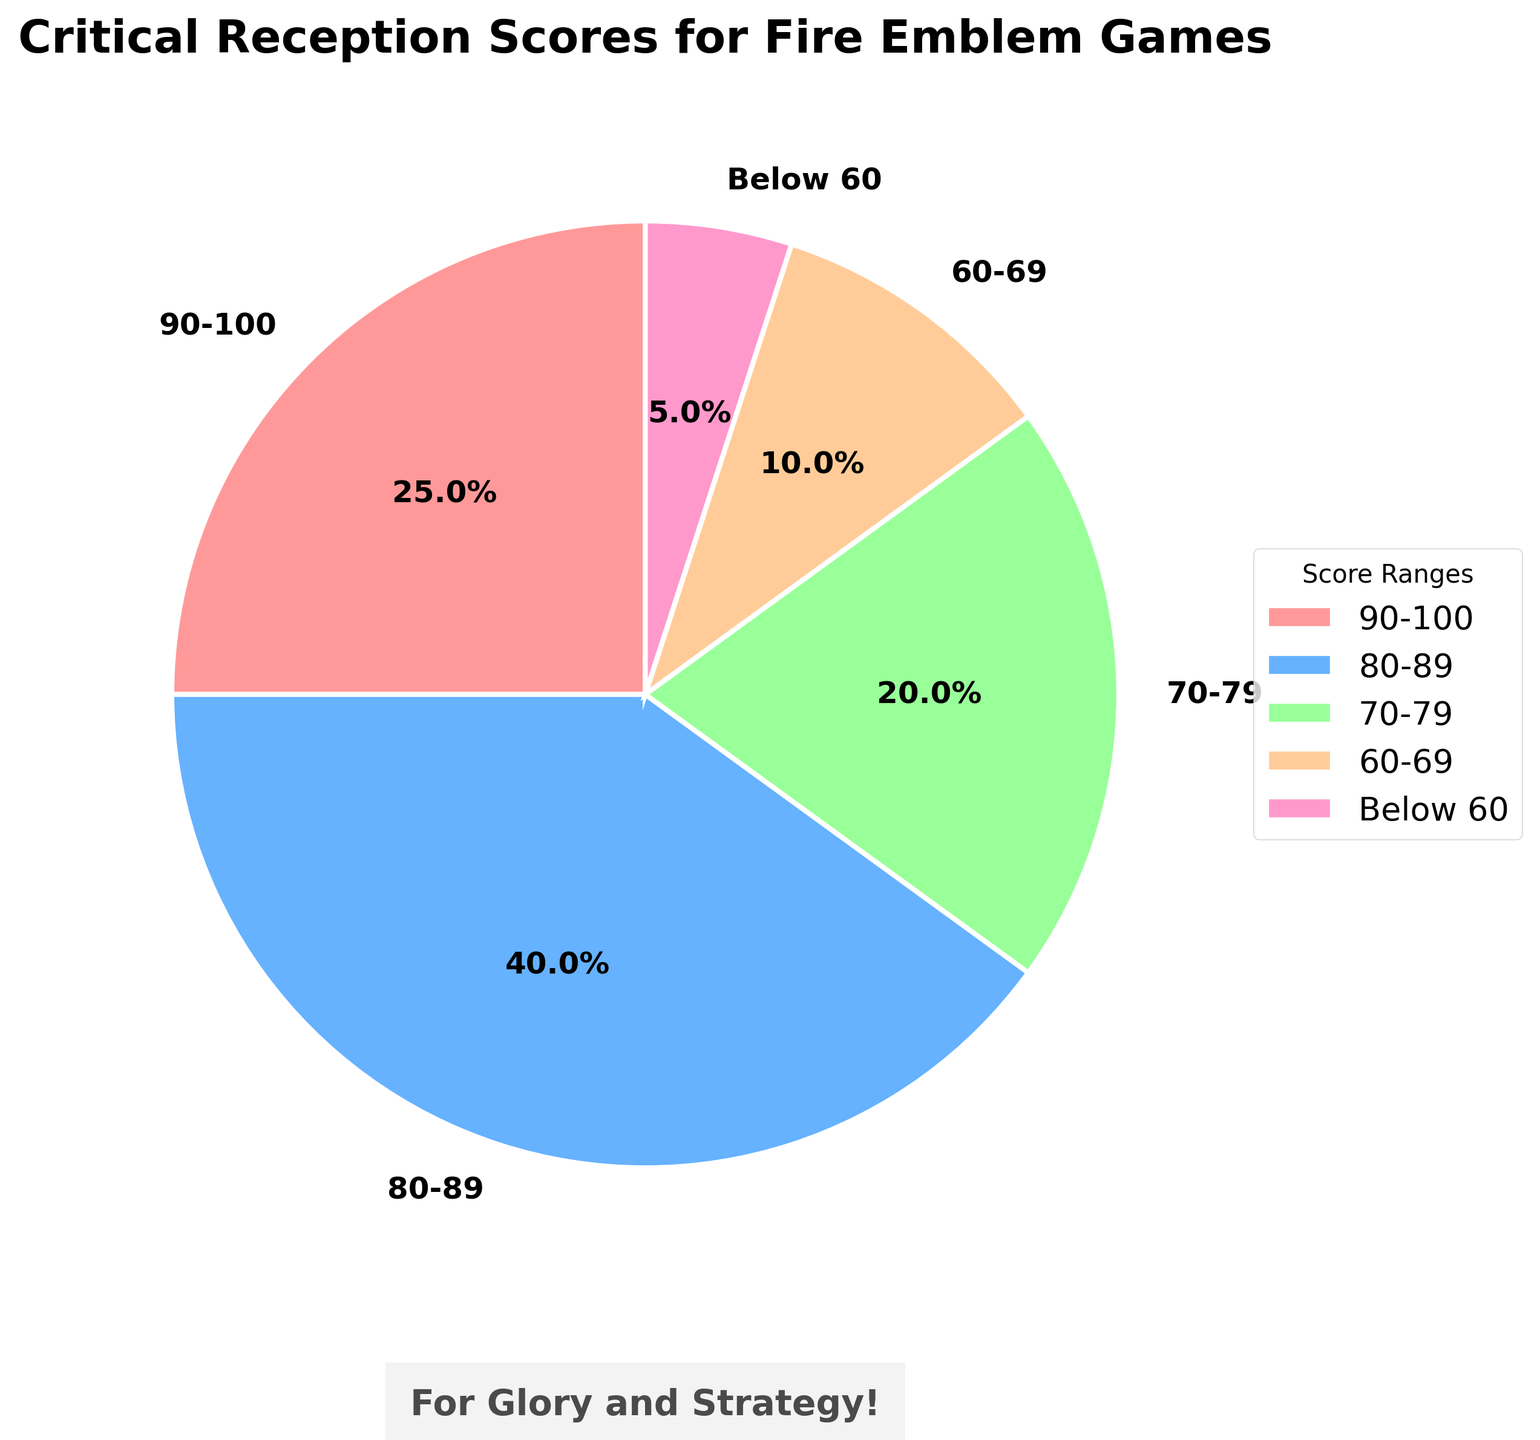What percentage of Fire Emblem games have received a score between 90-100? Looking at the pie chart, the section labeled "90-100" represents 25% of the total.
Answer: 25% What score range has the most games? The pie chart shows the largest section belongs to the "80-89" range, representing 40%.
Answer: 80-89 If you combined the percentages of games that scored below 70, what would be the total? Adding up the percentages of games scoring 60-69 and below 60: 10% + 5% = 15%.
Answer: 15% Which two score ranges together make up 60% of the total? From the chart, the "80-89" category is 40% and the "90-100" category is 25%. Together, they add up to 65%, so choose "80-89" (40%) and "70-79" (20%), which add up to 60%.
Answer: 80-89 and 70-79 How much more percentage of games received 80-89 scores as compared to those that received 70-79 scores? The percentage for the range "80-89" is 40%, and for "70-79" it is 20%. The difference is 40% - 20% = 20%.
Answer: 20% Which score range represents the smallest portion of the total? The pie chart shows the smallest section labeled "Below 60", representing 5%.
Answer: Below 60 What is the total percentage of games scoring 70 or above? Adding up the percentages for the ranges "70-79", "80-89", and "90-100": 20% + 40% + 25% = 85%.
Answer: 85% Is it true that less than 50% of the games have scores below 80? Adding the percentages for the ranges "60-69" and "Below 60": 10% + 5% = 15%. This is less than 50%.
Answer: True Calculate the average percentage of games in the "70-79" and "80-89" score ranges. Adding the percentages for the "70–79" range (20%) and the "80-89" range (40%) gives a total of 60%. Since there are 2 ranges, the average is 60% / 2 = 30%.
Answer: 30% Which two score ranges together make up the second largest portion after the "80-89" range? The "90-100" range (25%) and the "70-79" range (20%) together make up 45%, which is the second largest after "80-89" (40%).
Answer: 90-100 and 70-79 